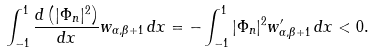<formula> <loc_0><loc_0><loc_500><loc_500>\int _ { - 1 } ^ { 1 } \frac { d \left ( | \Phi _ { n } | ^ { 2 } \right ) } { d x } w _ { \alpha , \beta + 1 } \, d x = - \int _ { - 1 } ^ { 1 } | \Phi _ { n } | ^ { 2 } w _ { \alpha , \beta + 1 } ^ { \prime } \, d x < 0 .</formula> 